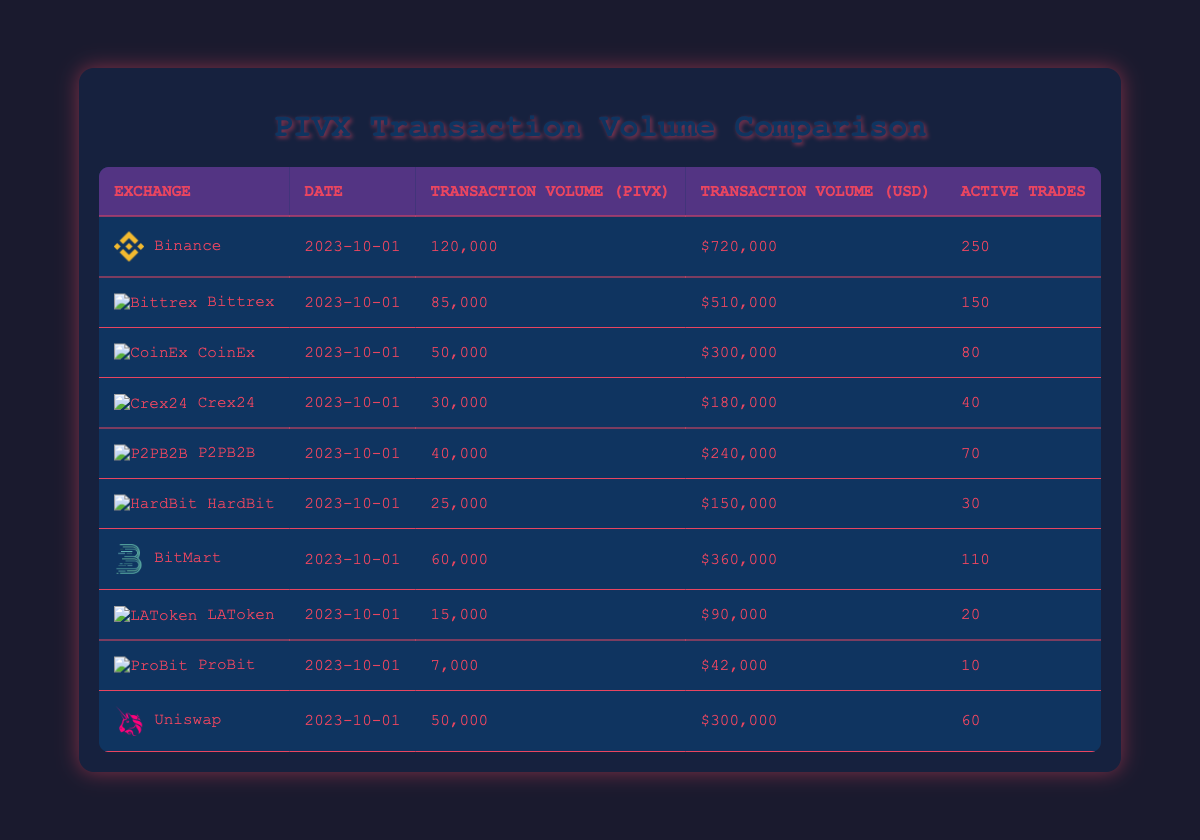What is the transaction volume of PIVX on Binance? The table shows the transaction volume for each exchange. For Binance, the Transaction Volume (PIVX) is listed as 120,000.
Answer: 120,000 Which exchange had the highest transaction volume in USD? By comparing the Transaction Volume (USD) column, Binance has the highest volume at $720,000.
Answer: Binance How many active trades were there on Bittrex? The table indicates that Bittrex had 150 active trades on the specified date.
Answer: 150 What is the total transaction volume of PIVX across all exchanges? Summing the Transaction Volume (PIVX): 120,000 + 85,000 + 50,000 + 30,000 + 40,000 + 25,000 + 60,000 + 15,000 + 7,000 + 50,000 = 412,000.
Answer: 412,000 Which exchange had the least transaction volume of PIVX? By examining the Transaction Volume (PIVX) values, ProBit had the least with a volume of 7,000.
Answer: ProBit What is the average transaction volume of PIVX across the exchanges listed? To find the average, first sum the total transaction volumes (412,000) and divide by the number of exchanges (10), resulting in an average of 41,200.
Answer: 41,200 Did LAToken have more transaction volume in PIVX compared to HardBit? LAToken had 15,000 while HardBit had 25,000; therefore, LAToken had less.
Answer: No Which exchange had a transaction volume of exactly 50,000 PIVX? The table shows that both CoinEx and Uniswap have a transaction volume of 50,000 PIVX.
Answer: CoinEx and Uniswap What was the total active trades among all the exchanges? Adding the active trades together: 250 + 150 + 80 + 40 + 70 + 30 + 110 + 20 + 10 + 60 = 820.
Answer: 820 Which exchange had a transaction volume greater than 200,000 USD? Looking through the Transaction Volume (USD), Binance ($720,000) and Bittrex ($510,000) meet this criterion.
Answer: Binance and Bittrex 